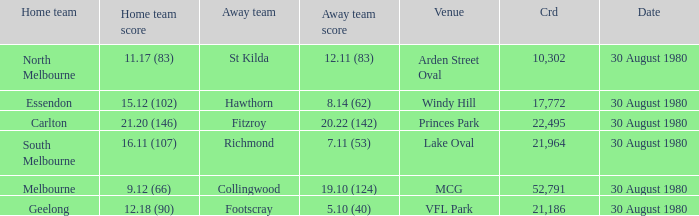What was the crowd when the away team is footscray? 21186.0. 